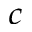<formula> <loc_0><loc_0><loc_500><loc_500>^ { c }</formula> 